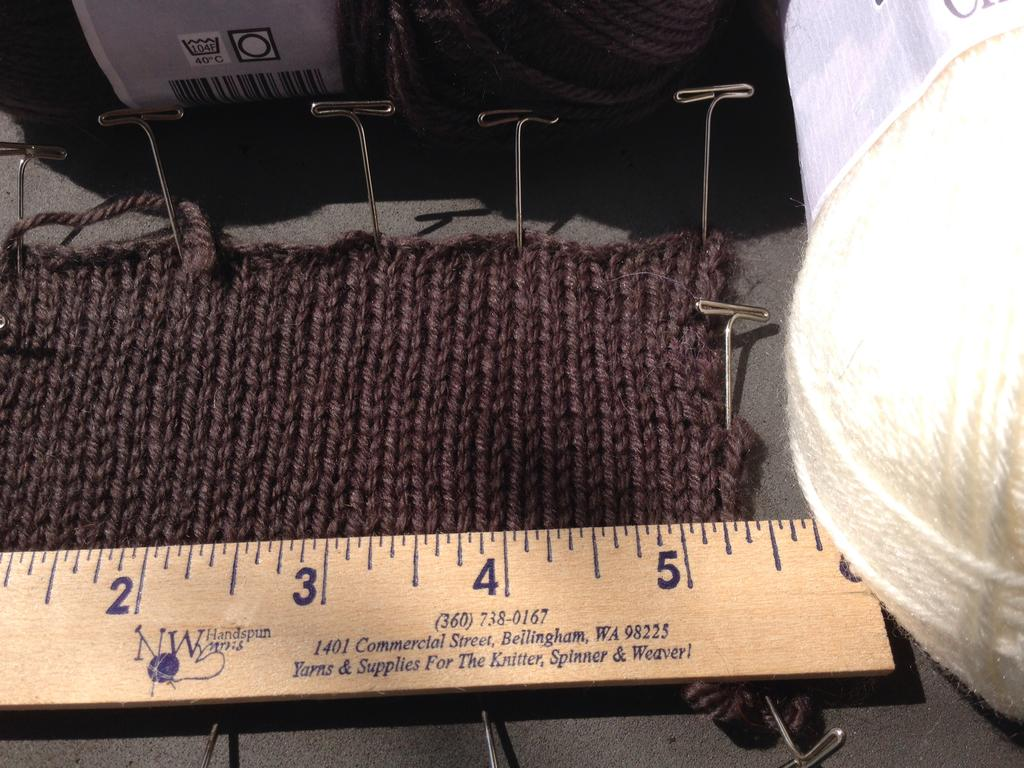Provide a one-sentence caption for the provided image. Ruler that is on a surface and says the address is in 98225. 